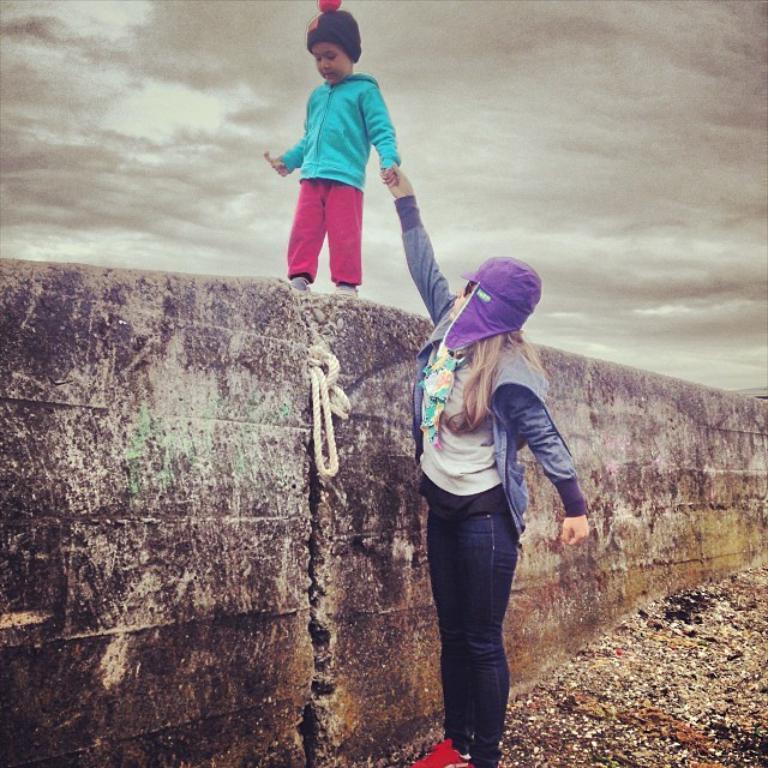Describe this image in one or two sentences. In this image we can see a woman standing on the ground and also we can see a kid holding an object and walking on the wall, in the background we can see the sky with clouds. 